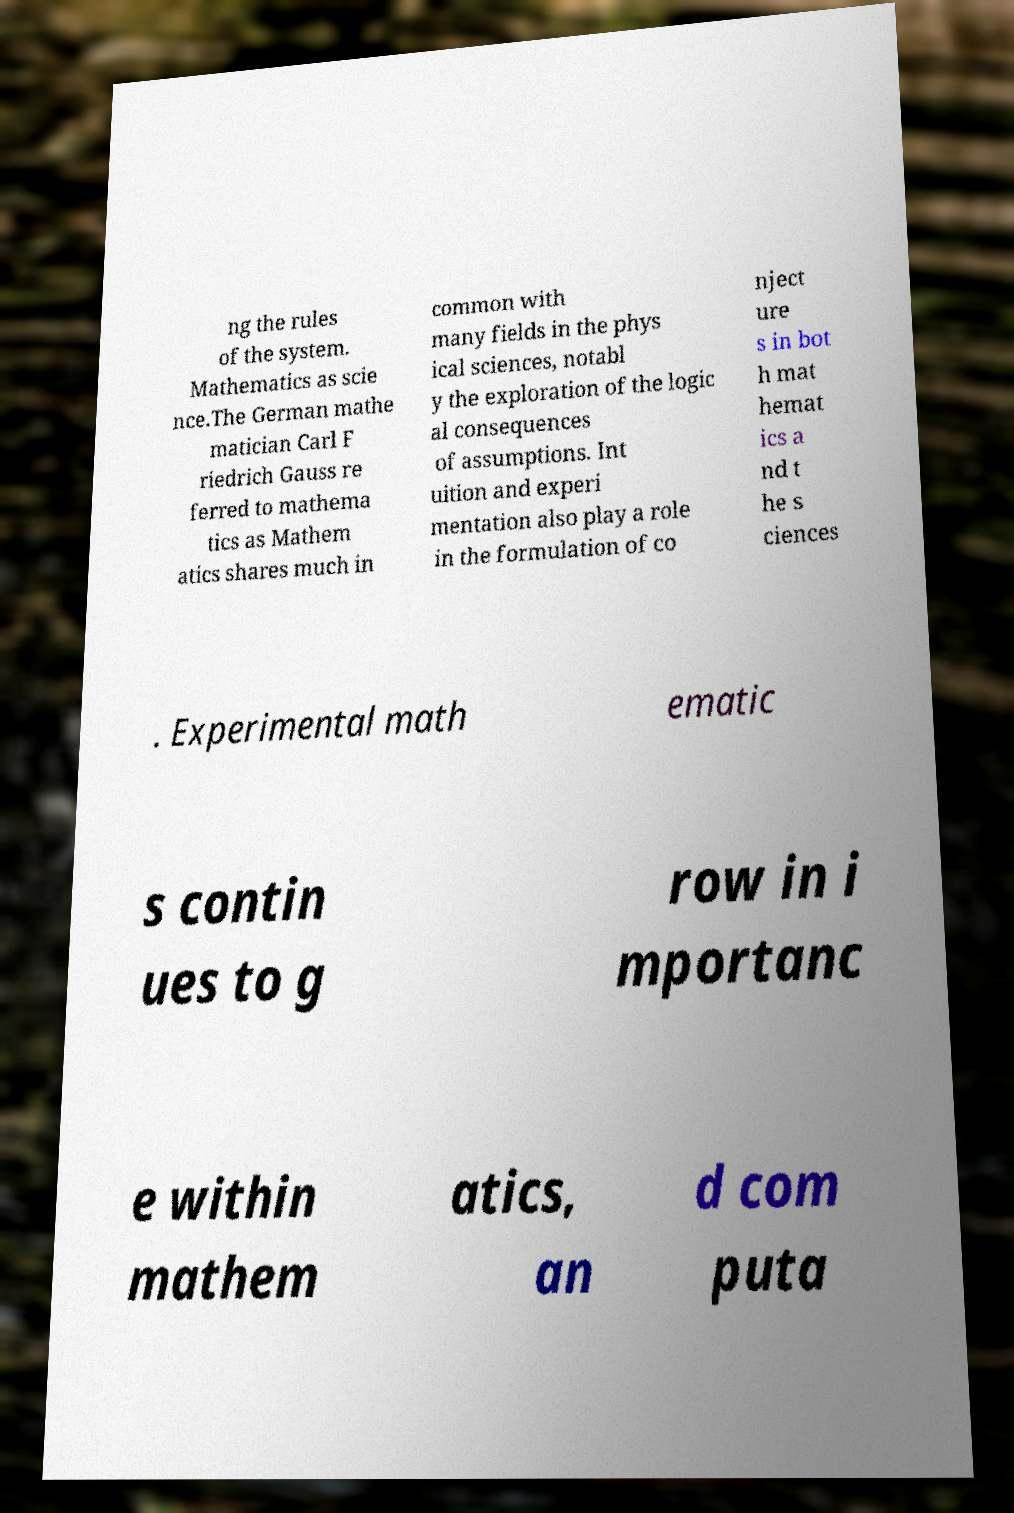I need the written content from this picture converted into text. Can you do that? ng the rules of the system. Mathematics as scie nce.The German mathe matician Carl F riedrich Gauss re ferred to mathema tics as Mathem atics shares much in common with many fields in the phys ical sciences, notabl y the exploration of the logic al consequences of assumptions. Int uition and experi mentation also play a role in the formulation of co nject ure s in bot h mat hemat ics a nd t he s ciences . Experimental math ematic s contin ues to g row in i mportanc e within mathem atics, an d com puta 